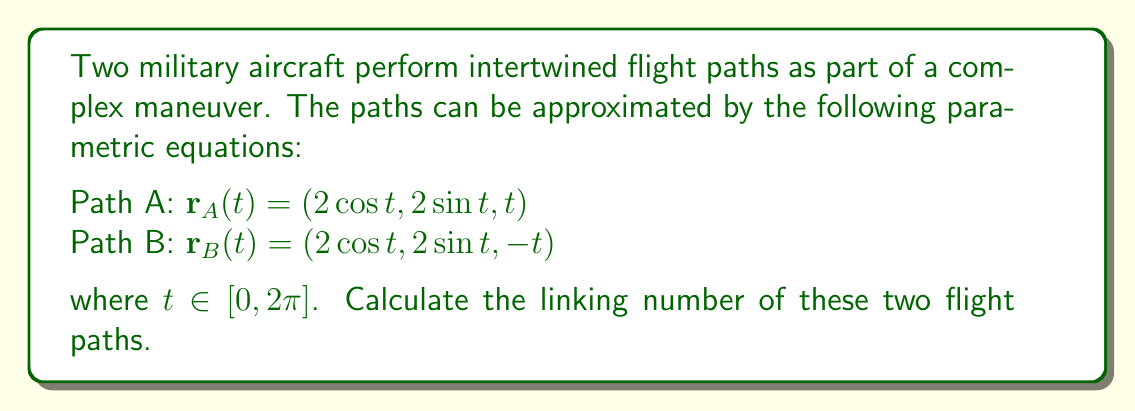Can you answer this question? To calculate the linking number of two closed curves, we can use the Gauss linking integral:

$$\text{Lk}(A,B) = \frac{1}{4\pi} \oint_A \oint_B \frac{(\mathbf{r}_A - \mathbf{r}_B) \cdot (d\mathbf{r}_A \times d\mathbf{r}_B)}{|\mathbf{r}_A - \mathbf{r}_B|^3}$$

1. First, we calculate $\mathbf{r}_A - \mathbf{r}_B$:
   $\mathbf{r}_A - \mathbf{r}_B = (0, 0, 2t)$

2. Next, we calculate $d\mathbf{r}_A$ and $d\mathbf{r}_B$:
   $d\mathbf{r}_A = (-2\sin t, 2\cos t, 1)dt$
   $d\mathbf{r}_B = (-2\sin t, 2\cos t, -1)dt$

3. Calculate $d\mathbf{r}_A \times d\mathbf{r}_B$:
   $d\mathbf{r}_A \times d\mathbf{r}_B = (4\cos t, 4\sin t, 0)dt^2$

4. Calculate $(\mathbf{r}_A - \mathbf{r}_B) \cdot (d\mathbf{r}_A \times d\mathbf{r}_B)$:
   $(0, 0, 2t) \cdot (4\cos t, 4\sin t, 0)dt^2 = 0$

5. Since the dot product is zero, the linking number is also zero.

This result indicates that the two flight paths, despite appearing intertwined, have a linking number of 0. This is because the paths can be continuously deformed to separate them without intersection.
Answer: $\text{Lk}(A,B) = 0$ 